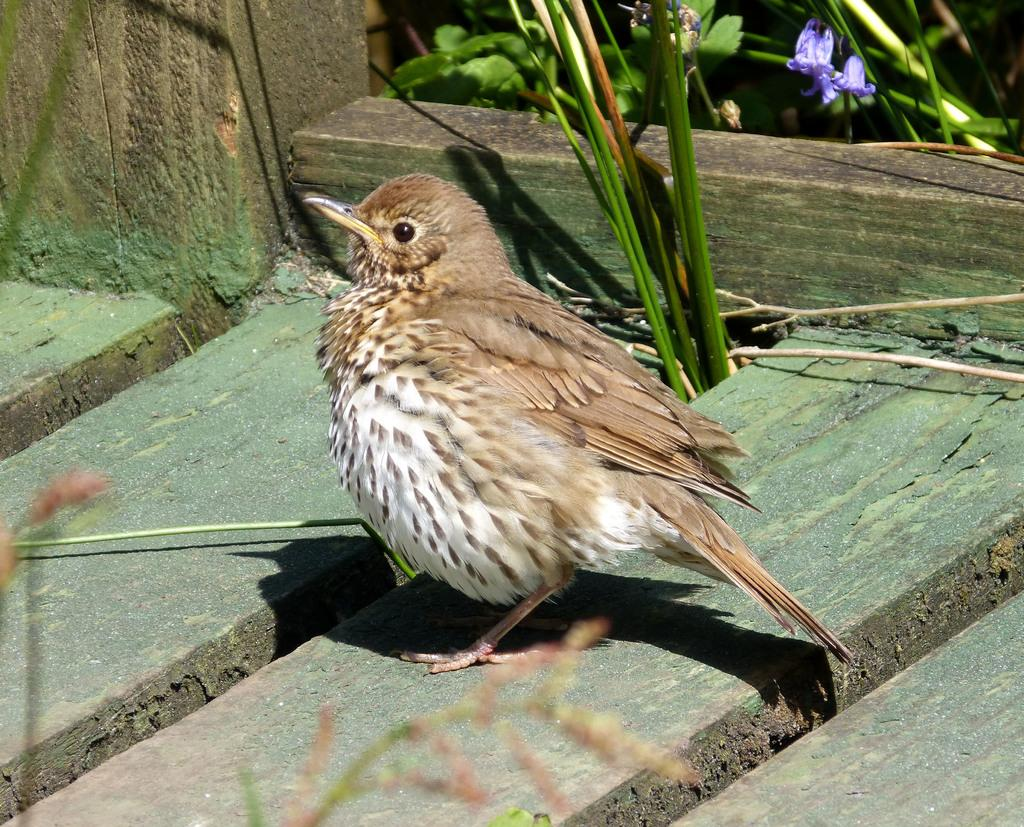What type of animal can be seen in the image? There is a bird in the image. Where is the bird located? The bird is on a wooden plank. What other natural elements are present in the image? There are plants and flowers in the image. What type of insurance does the bird have in the image? There is no mention of insurance in the image, as it features a bird on a wooden plank with plants and flowers. 